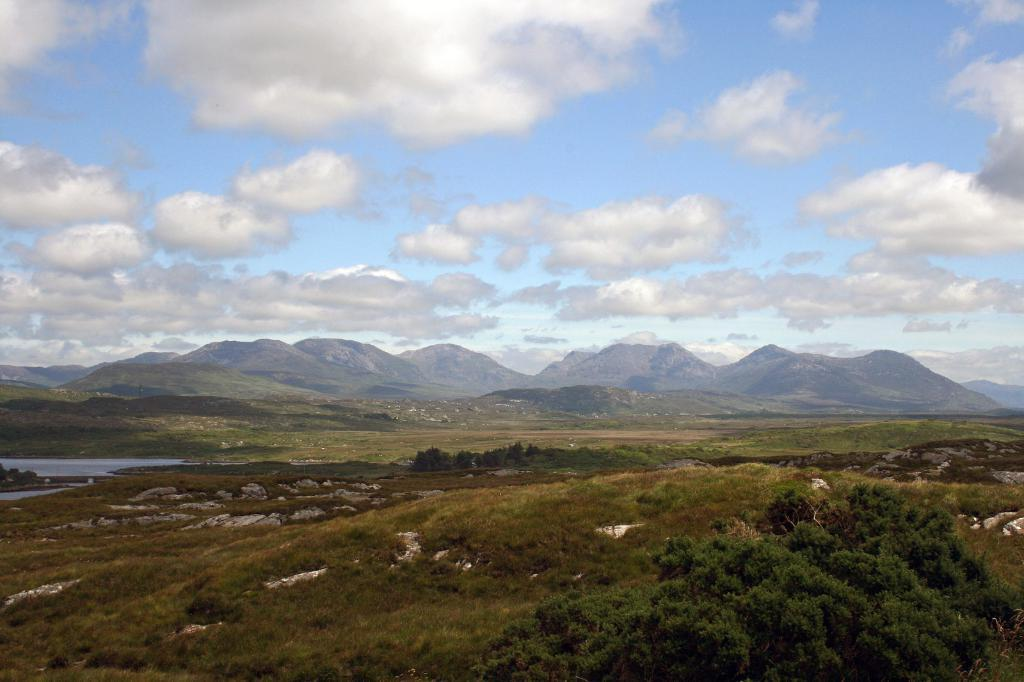What type of vegetation can be seen in the image? There are trees in the image. What is the color of the trees? The trees are green in color. What else can be seen in the image besides the trees? There is water visible in the image. What is visible in the background of the image? There are mountains in the background of the image. What colors can be seen in the sky in the image? The sky is blue and white in color. How many gold clocks can be seen hanging from the trees in the image? There are no gold clocks present in the image; it features trees, water, mountains, and a blue and white sky. What type of finger can be seen interacting with the trees in the image? There are no fingers present in the image; it only shows trees, water, mountains, and a blue and white sky. 